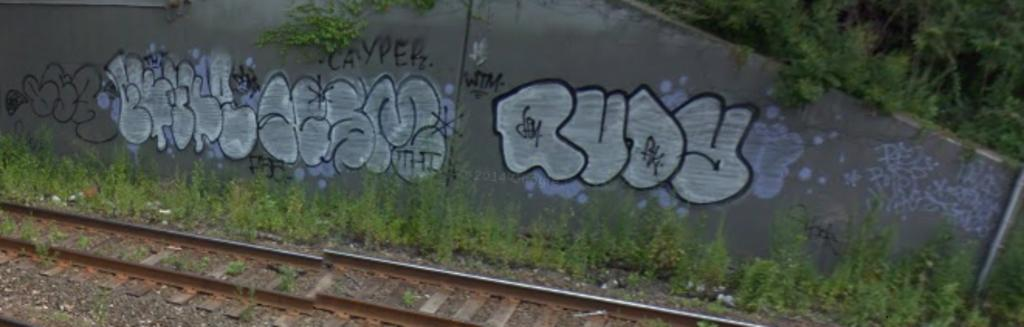<image>
Provide a brief description of the given image. The name Rudy is written in puffy letters on a cement wall. 